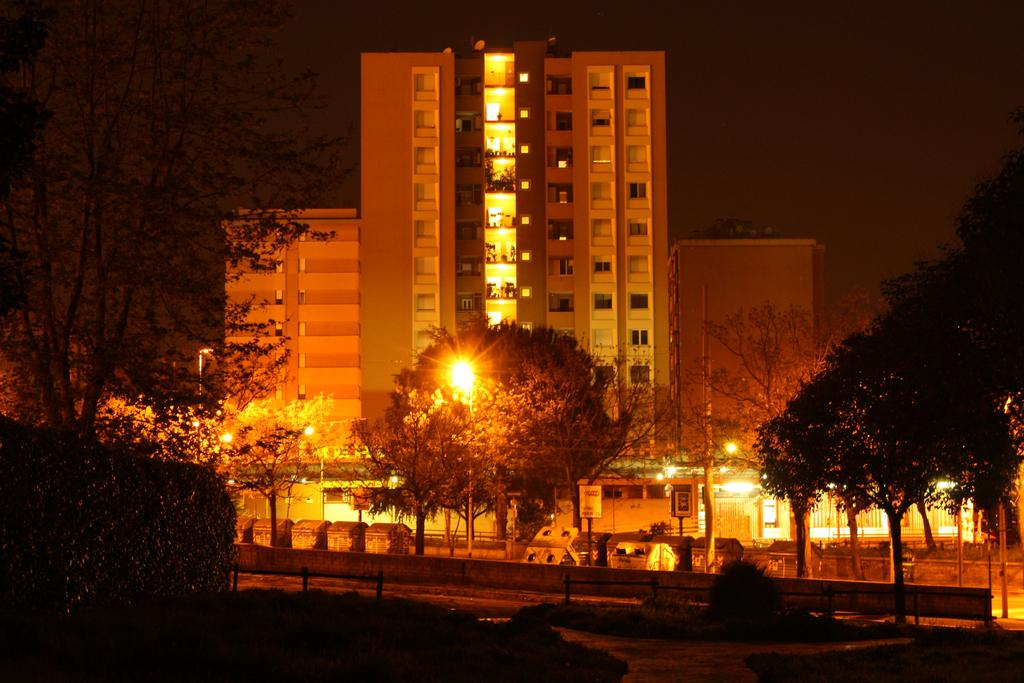What type of vegetation can be seen in the image? There are trees in the image. What structures are present in the image? There are poles, name boards, sign boards, bins, lights, a fence, and a building in the image. What is the ground surface like in the image? There is a road at the bottom of the image. What part of the natural environment is visible in the image? The sky is visible at the top of the image. What is the purpose of the duck in the image? There is no duck present in the image. Can you describe the sidewalk in the image? There is no sidewalk mentioned in the provided facts, so it cannot be described. 